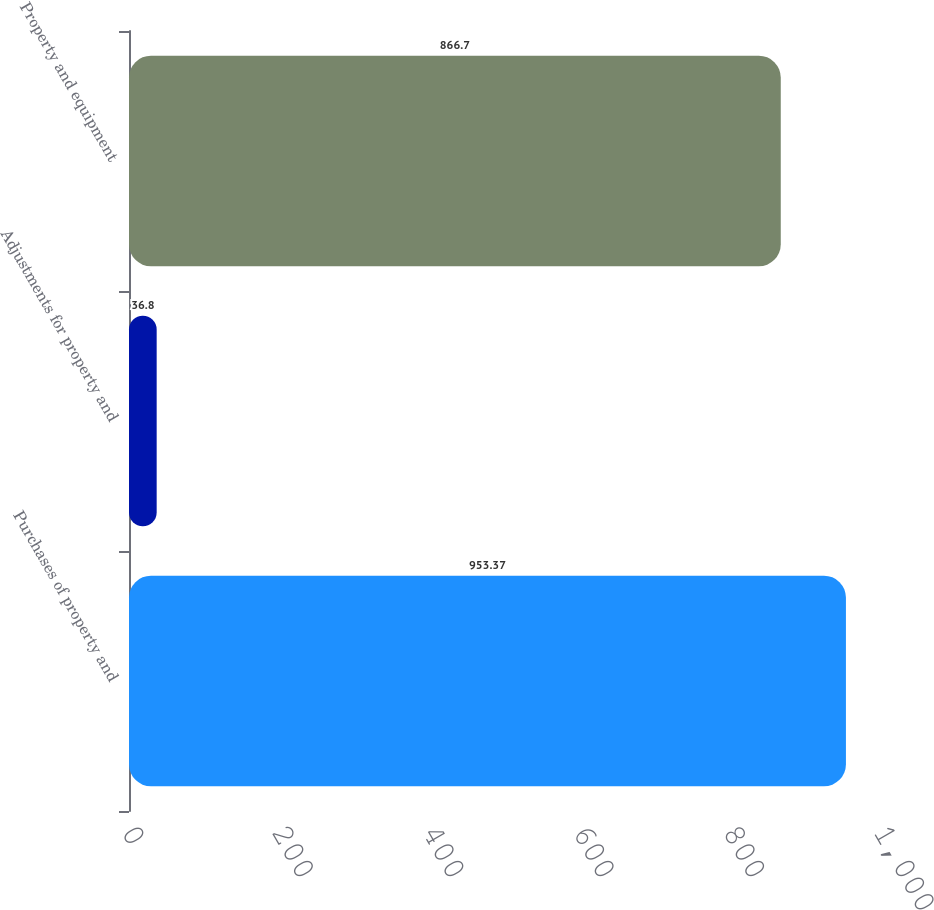Convert chart. <chart><loc_0><loc_0><loc_500><loc_500><bar_chart><fcel>Purchases of property and<fcel>Adjustments for property and<fcel>Property and equipment<nl><fcel>953.37<fcel>36.8<fcel>866.7<nl></chart> 